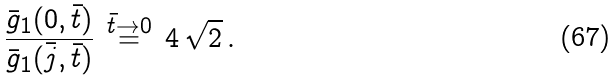Convert formula to latex. <formula><loc_0><loc_0><loc_500><loc_500>\frac { \bar { g } _ { 1 } ( 0 , \bar { t } ) } { \bar { g } _ { 1 } ( \bar { j } , \bar { t } ) } \, \stackrel { \bar { t } \rightarrow 0 } { = } \, 4 \, \sqrt { 2 } \, .</formula> 